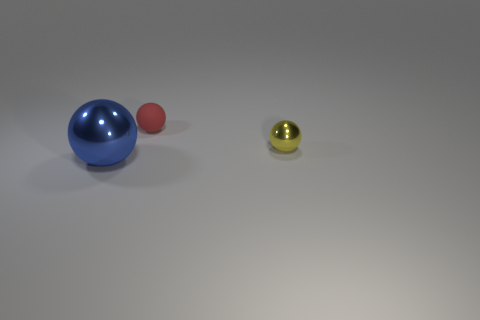What number of things are either big things that are in front of the matte thing or metallic balls left of the small metal object?
Make the answer very short. 1. There is a small ball behind the small yellow metallic thing; how many tiny yellow shiny things are to the right of it?
Provide a succinct answer. 1. What color is the other ball that is the same material as the large blue sphere?
Your response must be concise. Yellow. Are there any red rubber things that have the same size as the blue shiny thing?
Keep it short and to the point. No. The object that is the same size as the matte ball is what shape?
Make the answer very short. Sphere. Is there another red thing that has the same shape as the tiny red rubber thing?
Make the answer very short. No. Do the yellow object and the tiny ball behind the yellow sphere have the same material?
Your response must be concise. No. Is there a rubber ball of the same color as the tiny metal sphere?
Keep it short and to the point. No. How many other objects are there of the same material as the blue thing?
Your answer should be compact. 1. There is a tiny shiny thing; is it the same color as the thing that is left of the red object?
Offer a terse response. No. 